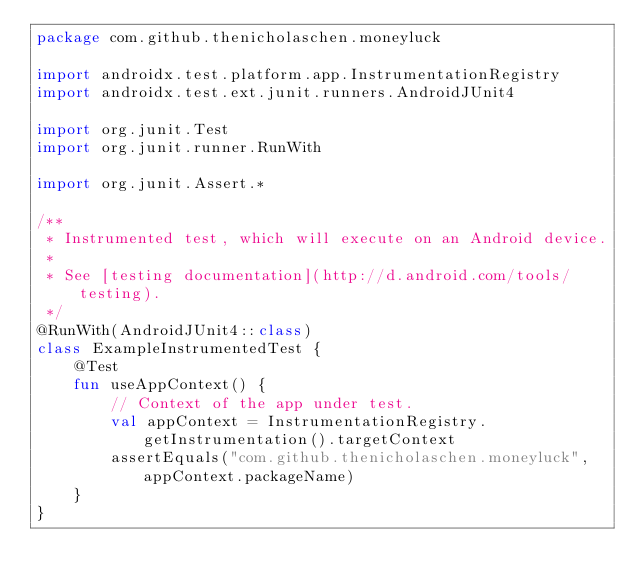<code> <loc_0><loc_0><loc_500><loc_500><_Kotlin_>package com.github.thenicholaschen.moneyluck

import androidx.test.platform.app.InstrumentationRegistry
import androidx.test.ext.junit.runners.AndroidJUnit4

import org.junit.Test
import org.junit.runner.RunWith

import org.junit.Assert.*

/**
 * Instrumented test, which will execute on an Android device.
 *
 * See [testing documentation](http://d.android.com/tools/testing).
 */
@RunWith(AndroidJUnit4::class)
class ExampleInstrumentedTest {
    @Test
    fun useAppContext() {
        // Context of the app under test.
        val appContext = InstrumentationRegistry.getInstrumentation().targetContext
        assertEquals("com.github.thenicholaschen.moneyluck", appContext.packageName)
    }
}
</code> 